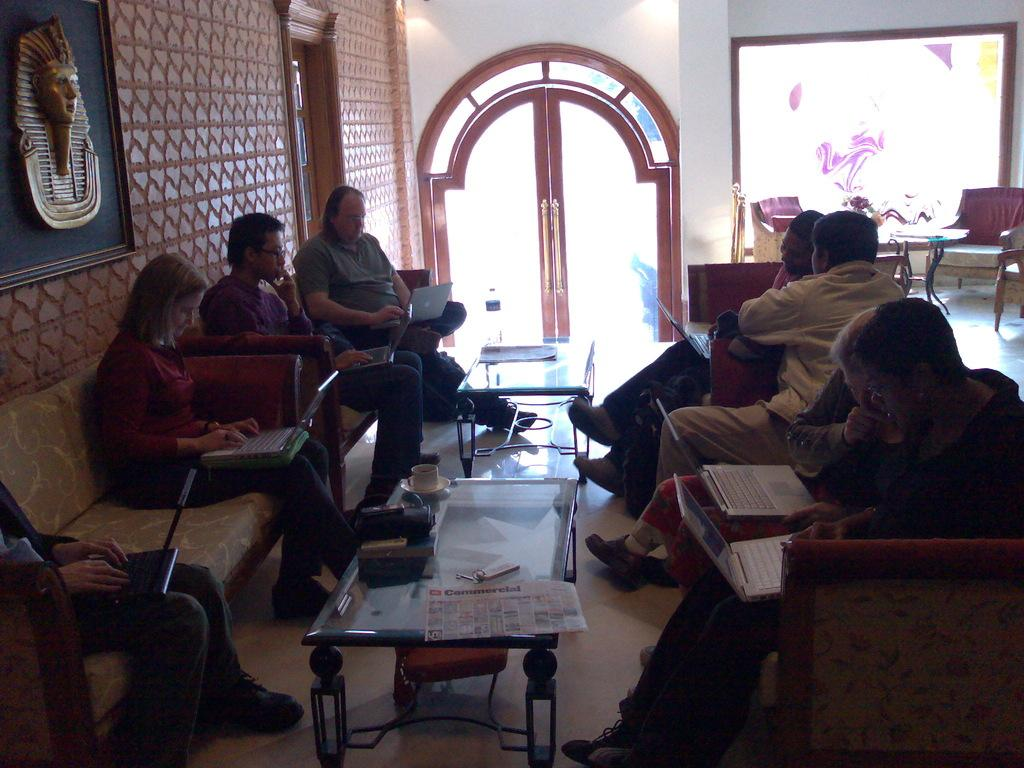What type of structure can be seen in the image? There is a wall in the image. Is there an entrance visible in the image? Yes, there is a door in the image. What is present on the wall in the image? There is a screen on the wall. What are the people in the image doing? The people are sitting on a sofa in the image. What is on the table in the image? There are papers, keys, and a bag on the table. What type of amusement can be seen in the image? There is no amusement present in the image; it features a wall, door, screen, sofa, table, papers, keys, and a bag. Can you hear a whistle in the image? There is no sound present in the image, so it is not possible to hear a whistle. 